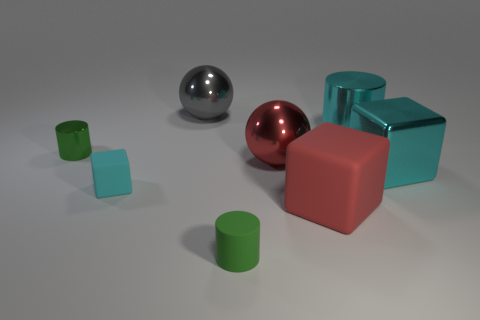Subtract all cyan blocks. How many were subtracted if there are1cyan blocks left? 1 Subtract all tiny blocks. How many blocks are left? 2 Subtract all red blocks. How many blocks are left? 2 Add 1 large purple metallic things. How many objects exist? 9 Subtract all cubes. How many objects are left? 5 Subtract 1 blocks. How many blocks are left? 2 Subtract all green balls. Subtract all red blocks. How many balls are left? 2 Subtract all cyan cylinders. How many red spheres are left? 1 Subtract all large metal objects. Subtract all large shiny objects. How many objects are left? 0 Add 8 tiny green shiny objects. How many tiny green shiny objects are left? 9 